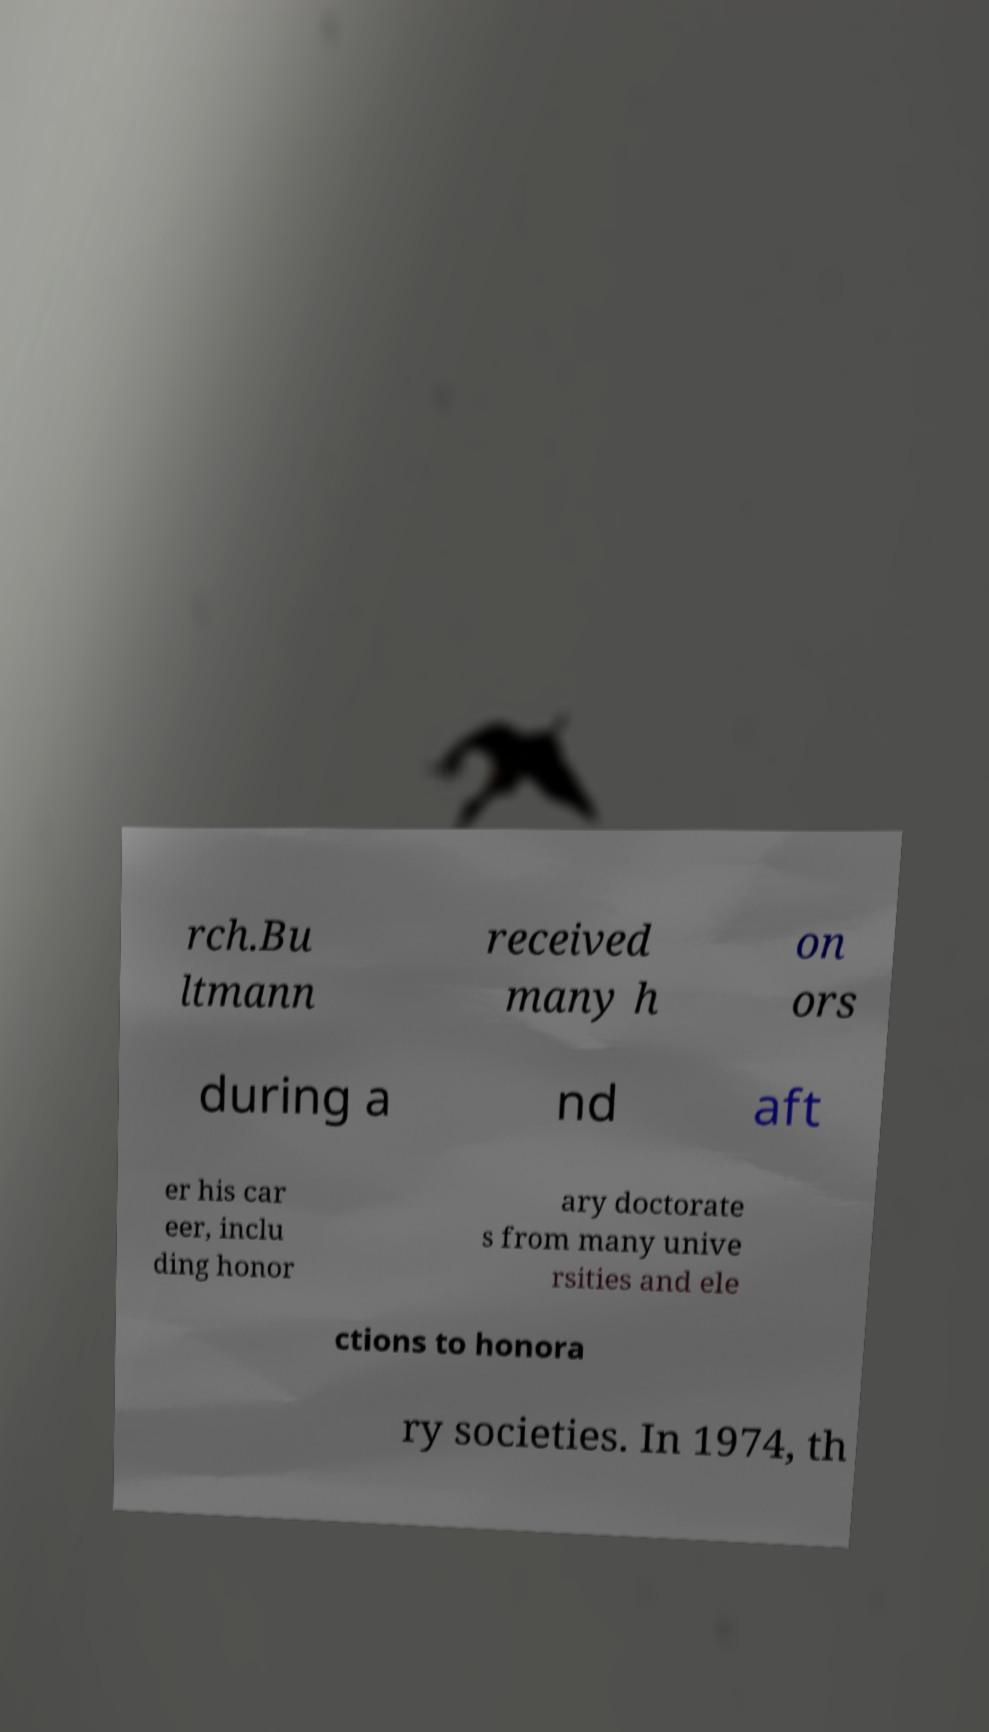Could you extract and type out the text from this image? rch.Bu ltmann received many h on ors during a nd aft er his car eer, inclu ding honor ary doctorate s from many unive rsities and ele ctions to honora ry societies. In 1974, th 